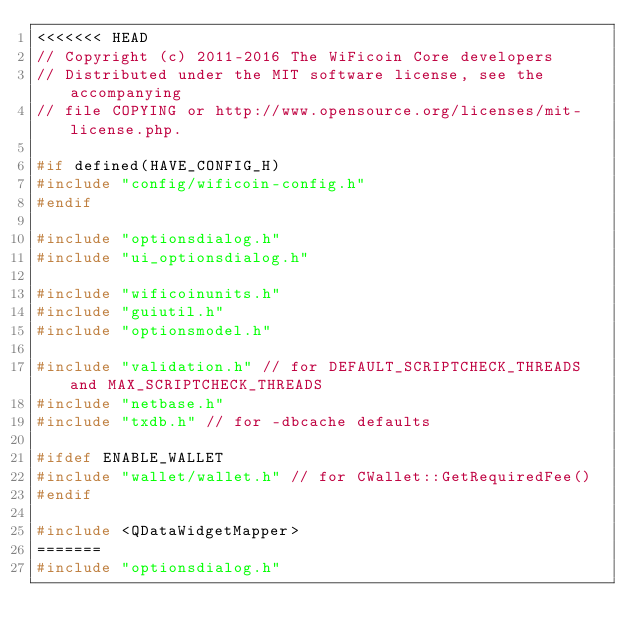<code> <loc_0><loc_0><loc_500><loc_500><_C++_><<<<<<< HEAD
// Copyright (c) 2011-2016 The WiFicoin Core developers
// Distributed under the MIT software license, see the accompanying
// file COPYING or http://www.opensource.org/licenses/mit-license.php.

#if defined(HAVE_CONFIG_H)
#include "config/wificoin-config.h"
#endif

#include "optionsdialog.h"
#include "ui_optionsdialog.h"

#include "wificoinunits.h"
#include "guiutil.h"
#include "optionsmodel.h"

#include "validation.h" // for DEFAULT_SCRIPTCHECK_THREADS and MAX_SCRIPTCHECK_THREADS
#include "netbase.h"
#include "txdb.h" // for -dbcache defaults

#ifdef ENABLE_WALLET
#include "wallet/wallet.h" // for CWallet::GetRequiredFee()
#endif

#include <QDataWidgetMapper>
=======
#include "optionsdialog.h"</code> 